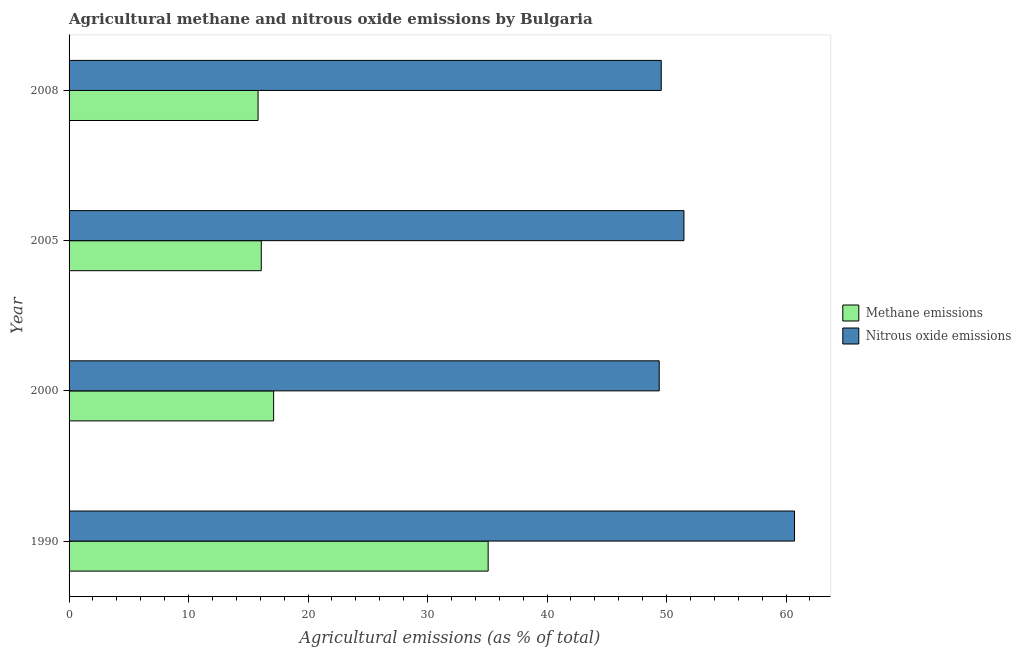Are the number of bars on each tick of the Y-axis equal?
Give a very brief answer. Yes. What is the label of the 3rd group of bars from the top?
Give a very brief answer. 2000. In how many cases, is the number of bars for a given year not equal to the number of legend labels?
Give a very brief answer. 0. What is the amount of methane emissions in 2000?
Provide a succinct answer. 17.12. Across all years, what is the maximum amount of methane emissions?
Provide a short and direct response. 35.07. Across all years, what is the minimum amount of methane emissions?
Your answer should be very brief. 15.82. In which year was the amount of nitrous oxide emissions minimum?
Your answer should be compact. 2000. What is the total amount of methane emissions in the graph?
Offer a very short reply. 84.09. What is the difference between the amount of methane emissions in 1990 and that in 2005?
Make the answer very short. 18.99. What is the difference between the amount of nitrous oxide emissions in 2008 and the amount of methane emissions in 1990?
Provide a succinct answer. 14.48. What is the average amount of nitrous oxide emissions per year?
Make the answer very short. 52.78. In the year 1990, what is the difference between the amount of methane emissions and amount of nitrous oxide emissions?
Make the answer very short. -25.64. In how many years, is the amount of nitrous oxide emissions greater than 30 %?
Your response must be concise. 4. What is the ratio of the amount of methane emissions in 1990 to that in 2000?
Your answer should be compact. 2.05. Is the amount of methane emissions in 2005 less than that in 2008?
Ensure brevity in your answer.  No. Is the difference between the amount of nitrous oxide emissions in 2005 and 2008 greater than the difference between the amount of methane emissions in 2005 and 2008?
Your answer should be very brief. Yes. What is the difference between the highest and the second highest amount of nitrous oxide emissions?
Ensure brevity in your answer.  9.25. What is the difference between the highest and the lowest amount of nitrous oxide emissions?
Offer a very short reply. 11.32. In how many years, is the amount of methane emissions greater than the average amount of methane emissions taken over all years?
Your answer should be compact. 1. Is the sum of the amount of methane emissions in 2005 and 2008 greater than the maximum amount of nitrous oxide emissions across all years?
Your answer should be very brief. No. What does the 1st bar from the top in 2000 represents?
Provide a short and direct response. Nitrous oxide emissions. What does the 2nd bar from the bottom in 2000 represents?
Offer a very short reply. Nitrous oxide emissions. How many bars are there?
Offer a very short reply. 8. What is the difference between two consecutive major ticks on the X-axis?
Ensure brevity in your answer.  10. Are the values on the major ticks of X-axis written in scientific E-notation?
Make the answer very short. No. Where does the legend appear in the graph?
Ensure brevity in your answer.  Center right. How many legend labels are there?
Provide a succinct answer. 2. What is the title of the graph?
Your answer should be compact. Agricultural methane and nitrous oxide emissions by Bulgaria. What is the label or title of the X-axis?
Make the answer very short. Agricultural emissions (as % of total). What is the label or title of the Y-axis?
Provide a short and direct response. Year. What is the Agricultural emissions (as % of total) of Methane emissions in 1990?
Keep it short and to the point. 35.07. What is the Agricultural emissions (as % of total) of Nitrous oxide emissions in 1990?
Keep it short and to the point. 60.71. What is the Agricultural emissions (as % of total) in Methane emissions in 2000?
Your response must be concise. 17.12. What is the Agricultural emissions (as % of total) of Nitrous oxide emissions in 2000?
Your answer should be very brief. 49.39. What is the Agricultural emissions (as % of total) of Methane emissions in 2005?
Ensure brevity in your answer.  16.08. What is the Agricultural emissions (as % of total) in Nitrous oxide emissions in 2005?
Provide a short and direct response. 51.46. What is the Agricultural emissions (as % of total) of Methane emissions in 2008?
Provide a short and direct response. 15.82. What is the Agricultural emissions (as % of total) in Nitrous oxide emissions in 2008?
Your answer should be very brief. 49.55. Across all years, what is the maximum Agricultural emissions (as % of total) in Methane emissions?
Offer a very short reply. 35.07. Across all years, what is the maximum Agricultural emissions (as % of total) of Nitrous oxide emissions?
Your answer should be very brief. 60.71. Across all years, what is the minimum Agricultural emissions (as % of total) of Methane emissions?
Offer a very short reply. 15.82. Across all years, what is the minimum Agricultural emissions (as % of total) of Nitrous oxide emissions?
Offer a very short reply. 49.39. What is the total Agricultural emissions (as % of total) in Methane emissions in the graph?
Ensure brevity in your answer.  84.09. What is the total Agricultural emissions (as % of total) in Nitrous oxide emissions in the graph?
Your response must be concise. 211.11. What is the difference between the Agricultural emissions (as % of total) of Methane emissions in 1990 and that in 2000?
Offer a terse response. 17.95. What is the difference between the Agricultural emissions (as % of total) of Nitrous oxide emissions in 1990 and that in 2000?
Offer a terse response. 11.32. What is the difference between the Agricultural emissions (as % of total) of Methane emissions in 1990 and that in 2005?
Keep it short and to the point. 18.99. What is the difference between the Agricultural emissions (as % of total) in Nitrous oxide emissions in 1990 and that in 2005?
Give a very brief answer. 9.25. What is the difference between the Agricultural emissions (as % of total) in Methane emissions in 1990 and that in 2008?
Make the answer very short. 19.26. What is the difference between the Agricultural emissions (as % of total) of Nitrous oxide emissions in 1990 and that in 2008?
Offer a terse response. 11.15. What is the difference between the Agricultural emissions (as % of total) in Methane emissions in 2000 and that in 2005?
Provide a succinct answer. 1.04. What is the difference between the Agricultural emissions (as % of total) in Nitrous oxide emissions in 2000 and that in 2005?
Provide a short and direct response. -2.07. What is the difference between the Agricultural emissions (as % of total) in Methane emissions in 2000 and that in 2008?
Provide a short and direct response. 1.3. What is the difference between the Agricultural emissions (as % of total) in Nitrous oxide emissions in 2000 and that in 2008?
Ensure brevity in your answer.  -0.17. What is the difference between the Agricultural emissions (as % of total) of Methane emissions in 2005 and that in 2008?
Make the answer very short. 0.27. What is the difference between the Agricultural emissions (as % of total) in Nitrous oxide emissions in 2005 and that in 2008?
Ensure brevity in your answer.  1.9. What is the difference between the Agricultural emissions (as % of total) of Methane emissions in 1990 and the Agricultural emissions (as % of total) of Nitrous oxide emissions in 2000?
Offer a terse response. -14.32. What is the difference between the Agricultural emissions (as % of total) in Methane emissions in 1990 and the Agricultural emissions (as % of total) in Nitrous oxide emissions in 2005?
Your answer should be very brief. -16.39. What is the difference between the Agricultural emissions (as % of total) of Methane emissions in 1990 and the Agricultural emissions (as % of total) of Nitrous oxide emissions in 2008?
Make the answer very short. -14.48. What is the difference between the Agricultural emissions (as % of total) in Methane emissions in 2000 and the Agricultural emissions (as % of total) in Nitrous oxide emissions in 2005?
Keep it short and to the point. -34.34. What is the difference between the Agricultural emissions (as % of total) in Methane emissions in 2000 and the Agricultural emissions (as % of total) in Nitrous oxide emissions in 2008?
Your response must be concise. -32.44. What is the difference between the Agricultural emissions (as % of total) of Methane emissions in 2005 and the Agricultural emissions (as % of total) of Nitrous oxide emissions in 2008?
Your answer should be compact. -33.47. What is the average Agricultural emissions (as % of total) of Methane emissions per year?
Provide a short and direct response. 21.02. What is the average Agricultural emissions (as % of total) in Nitrous oxide emissions per year?
Your answer should be compact. 52.78. In the year 1990, what is the difference between the Agricultural emissions (as % of total) in Methane emissions and Agricultural emissions (as % of total) in Nitrous oxide emissions?
Provide a succinct answer. -25.64. In the year 2000, what is the difference between the Agricultural emissions (as % of total) of Methane emissions and Agricultural emissions (as % of total) of Nitrous oxide emissions?
Provide a succinct answer. -32.27. In the year 2005, what is the difference between the Agricultural emissions (as % of total) in Methane emissions and Agricultural emissions (as % of total) in Nitrous oxide emissions?
Provide a short and direct response. -35.37. In the year 2008, what is the difference between the Agricultural emissions (as % of total) in Methane emissions and Agricultural emissions (as % of total) in Nitrous oxide emissions?
Keep it short and to the point. -33.74. What is the ratio of the Agricultural emissions (as % of total) of Methane emissions in 1990 to that in 2000?
Your answer should be very brief. 2.05. What is the ratio of the Agricultural emissions (as % of total) of Nitrous oxide emissions in 1990 to that in 2000?
Ensure brevity in your answer.  1.23. What is the ratio of the Agricultural emissions (as % of total) in Methane emissions in 1990 to that in 2005?
Keep it short and to the point. 2.18. What is the ratio of the Agricultural emissions (as % of total) in Nitrous oxide emissions in 1990 to that in 2005?
Keep it short and to the point. 1.18. What is the ratio of the Agricultural emissions (as % of total) in Methane emissions in 1990 to that in 2008?
Offer a very short reply. 2.22. What is the ratio of the Agricultural emissions (as % of total) in Nitrous oxide emissions in 1990 to that in 2008?
Make the answer very short. 1.23. What is the ratio of the Agricultural emissions (as % of total) in Methane emissions in 2000 to that in 2005?
Offer a very short reply. 1.06. What is the ratio of the Agricultural emissions (as % of total) in Nitrous oxide emissions in 2000 to that in 2005?
Keep it short and to the point. 0.96. What is the ratio of the Agricultural emissions (as % of total) in Methane emissions in 2000 to that in 2008?
Provide a short and direct response. 1.08. What is the ratio of the Agricultural emissions (as % of total) in Nitrous oxide emissions in 2000 to that in 2008?
Provide a short and direct response. 1. What is the ratio of the Agricultural emissions (as % of total) in Methane emissions in 2005 to that in 2008?
Your answer should be very brief. 1.02. What is the ratio of the Agricultural emissions (as % of total) in Nitrous oxide emissions in 2005 to that in 2008?
Offer a terse response. 1.04. What is the difference between the highest and the second highest Agricultural emissions (as % of total) in Methane emissions?
Ensure brevity in your answer.  17.95. What is the difference between the highest and the second highest Agricultural emissions (as % of total) in Nitrous oxide emissions?
Your answer should be very brief. 9.25. What is the difference between the highest and the lowest Agricultural emissions (as % of total) in Methane emissions?
Give a very brief answer. 19.26. What is the difference between the highest and the lowest Agricultural emissions (as % of total) of Nitrous oxide emissions?
Keep it short and to the point. 11.32. 